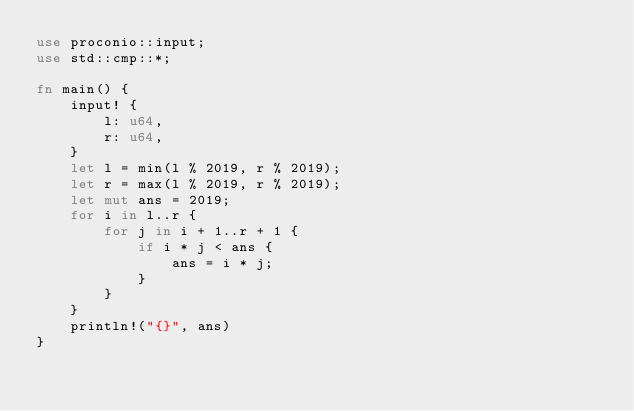Convert code to text. <code><loc_0><loc_0><loc_500><loc_500><_Rust_>use proconio::input;
use std::cmp::*;

fn main() {
    input! {
        l: u64,
        r: u64,
    }
    let l = min(l % 2019, r % 2019);
    let r = max(l % 2019, r % 2019);
    let mut ans = 2019;
    for i in l..r {
        for j in i + 1..r + 1 {
            if i * j < ans {
                ans = i * j;
            }
        }
    }
    println!("{}", ans)
}
</code> 